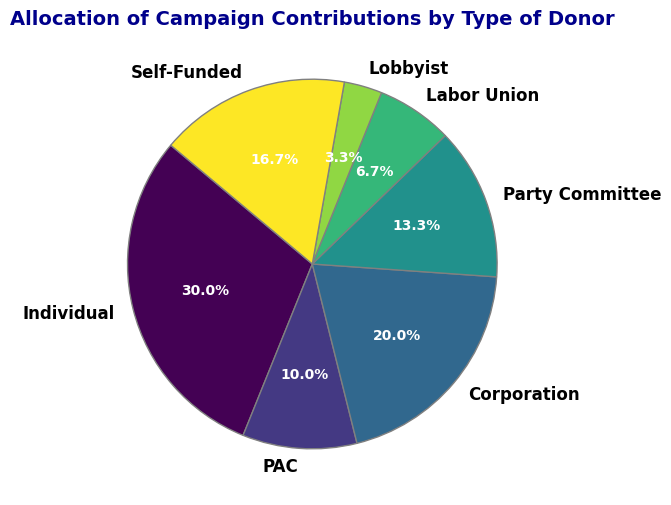What percentage of the total contributions is from Labor Unions? The pie chart shows that Labor Unions contribute 1,000,000. By summing up all contributions, we get 4,500,000 (Individual) + 1,500,000 (PAC) + 3,000,000 (Corporation) + 2,000,000 (Party Committee) + 1,000,000 (Labor Union) + 500,000 (Lobbyist) + 2,500,000 (Self-Funded) = 15,000,000. The percentage contributed by Labor Unions is (1,000,000 / 15,000,000) * 100 = 6.7%
Answer: 6.7% Which type of donor contributes the most and what is the amount? By visually examining the pie chart's segments, we see that 'Individual' donors have the largest segment, corresponding to 4,500,000 in contributions
Answer: Individual, 4,500,000 Which type of donor contributes the least and what is the amount? Observing the smallest segment in the pie chart, 'Lobbyist' donors contribute the least amount, which is 500,000
Answer: Lobbyist, 500,000 How do contributions from Corporations compare to contributions from Individual donors? The pie chart shows that Individuals contribute 4,500,000 and Corporations contribute 3,000,000. Therefore, Individual contributions are greater by 1,500,000
Answer: Individual contributions are greater by 1,500,000 What's the combined percentage of contributions from PACs and Party Committees? The pie chart indicates PAC contributions of 1,500,000 and Party Committee contributions of 2,000,000. The total contributions are 15,000,000, thus their combined percentage is ((1,500,000 + 2,000,000) / 15,000,000) * 100 = 23.3%
Answer: 23.3% How do the contributions from Self-Funded donors compare proportionally to Labor Union donors? The pie chart shows that Self-Funded contributes 2,500,000 and Labor Unions contribute 1,000,000. The total contributions amount to 15,000,000. The percentages are (2,500,000 / 15,000,000) * 100 = 16.7% for Self-Funded and (1,000,000 / 15,000,000) * 100 = 6.7% for Labor Unions. Thus, Self-Funded contributions are roughly 2.5 times higher than Labor Unions
Answer: Self-Funded contributions are roughly 2.5 times higher If the contributions were to increase uniformly by 10% for each donor type, how much would Individual contributions become? Increasing the Individual contributions of 4,500,000 by 10%, the new value is 4,500,000 * 1.10 = 4,950,000
Answer: 4,950,000 What is the difference in contributions between the top two donor types? The pie chart shows the top two donor types are 'Individual' with 4,500,000 and 'Self-Funded' with 2,500,000. The difference between them is 4,500,000 - 2,500,000 = 2,000,000
Answer: 2,000,000 What's the average contribution amount across all donor types? Summing all the contributions: 4,500,000 + 1,500,000 + 3,000,000 + 2,000,000 + 1,000,000 + 500,000 + 2,500,000 gives 15,000,000. With 7 donor types, the average is 15,000,000 / 7 ≈ 2,142,857
Answer: 2,142,857 